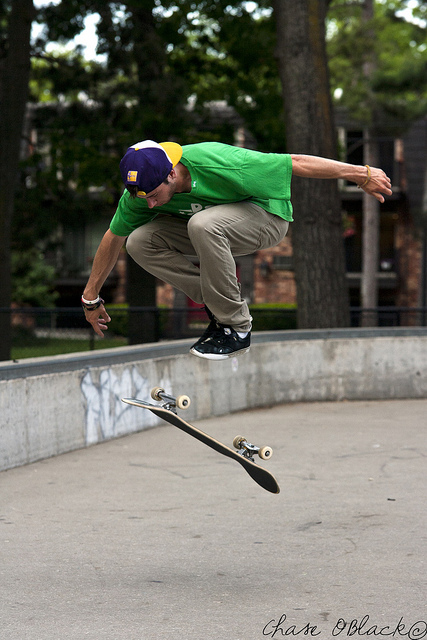Extract all visible text content from this image. chase OBlack&#169; &#169; 